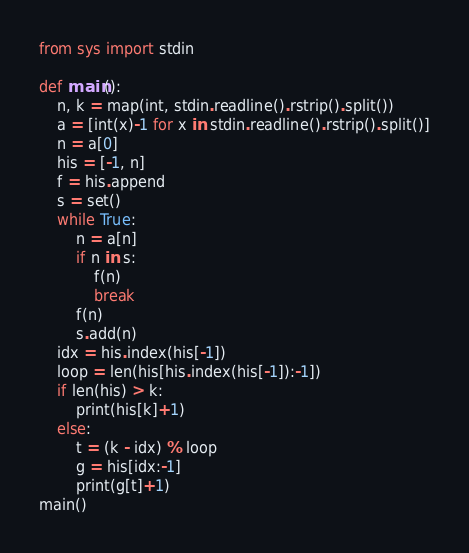<code> <loc_0><loc_0><loc_500><loc_500><_Python_>from sys import stdin

def main():
    n, k = map(int, stdin.readline().rstrip().split())
    a = [int(x)-1 for x in stdin.readline().rstrip().split()]
    n = a[0]
    his = [-1, n]
    f = his.append
    s = set()
    while True:
        n = a[n]
        if n in s:
            f(n)
            break
        f(n)
        s.add(n)
    idx = his.index(his[-1])
    loop = len(his[his.index(his[-1]):-1])
    if len(his) > k:
        print(his[k]+1)
    else:
        t = (k - idx) % loop
        g = his[idx:-1]
        print(g[t]+1)
main()</code> 